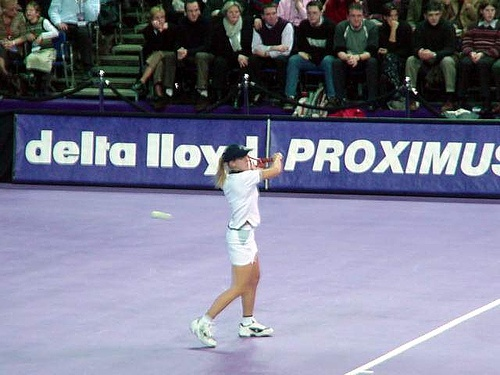Describe the objects in this image and their specific colors. I can see people in black, lightgray, darkgray, gray, and tan tones, people in black, gray, and darkgreen tones, people in black, gray, and darkgreen tones, people in black, gray, darkgreen, and teal tones, and people in black, gray, and darkgray tones in this image. 